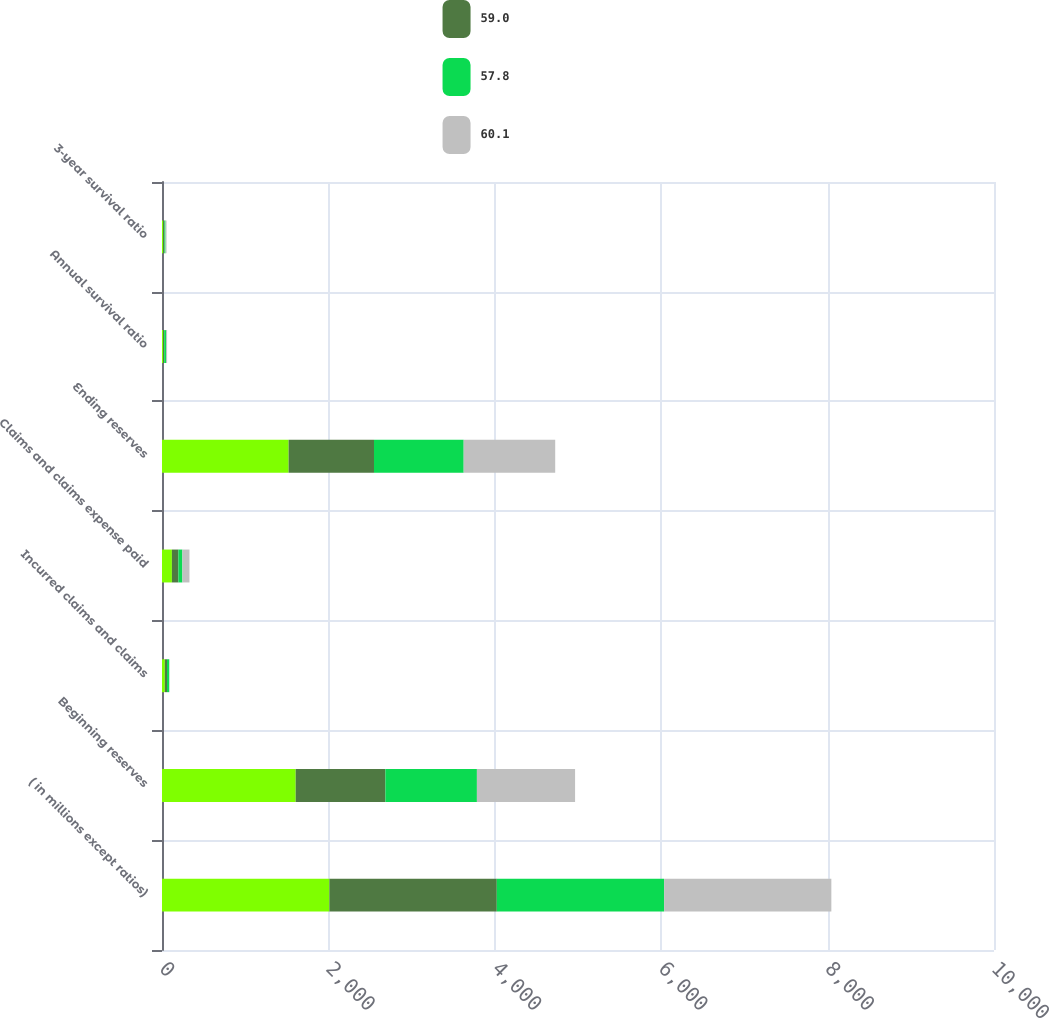Convert chart to OTSL. <chart><loc_0><loc_0><loc_500><loc_500><stacked_bar_chart><ecel><fcel>( in millions except ratios)<fcel>Beginning reserves<fcel>Incurred claims and claims<fcel>Claims and claims expense paid<fcel>Ending reserves<fcel>Annual survival ratio<fcel>3-year survival ratio<nl><fcel>nan<fcel>2012<fcel>1607<fcel>34<fcel>119<fcel>1522<fcel>12.8<fcel>14.1<nl><fcel>59<fcel>2012<fcel>1078<fcel>26<fcel>78<fcel>1026<fcel>13.2<fcel>14.7<nl><fcel>57.8<fcel>2011<fcel>1100<fcel>26<fcel>48<fcel>1078<fcel>22.5<fcel>13.6<nl><fcel>60.1<fcel>2010<fcel>1180<fcel>5<fcel>85<fcel>1100<fcel>12.9<fcel>12.2<nl></chart> 